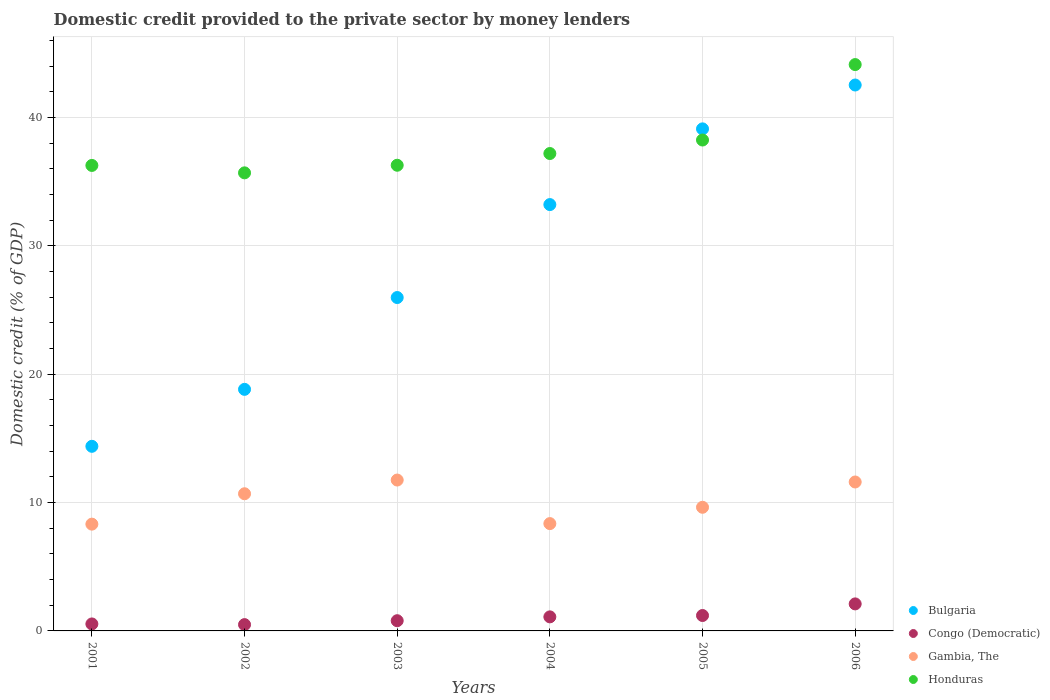How many different coloured dotlines are there?
Give a very brief answer. 4. What is the domestic credit provided to the private sector by money lenders in Gambia, The in 2006?
Provide a short and direct response. 11.61. Across all years, what is the maximum domestic credit provided to the private sector by money lenders in Honduras?
Give a very brief answer. 44.14. Across all years, what is the minimum domestic credit provided to the private sector by money lenders in Bulgaria?
Keep it short and to the point. 14.39. In which year was the domestic credit provided to the private sector by money lenders in Gambia, The maximum?
Keep it short and to the point. 2003. In which year was the domestic credit provided to the private sector by money lenders in Congo (Democratic) minimum?
Ensure brevity in your answer.  2002. What is the total domestic credit provided to the private sector by money lenders in Gambia, The in the graph?
Provide a succinct answer. 60.38. What is the difference between the domestic credit provided to the private sector by money lenders in Gambia, The in 2001 and that in 2003?
Offer a terse response. -3.44. What is the difference between the domestic credit provided to the private sector by money lenders in Honduras in 2004 and the domestic credit provided to the private sector by money lenders in Gambia, The in 2003?
Make the answer very short. 25.45. What is the average domestic credit provided to the private sector by money lenders in Congo (Democratic) per year?
Your answer should be compact. 1.04. In the year 2006, what is the difference between the domestic credit provided to the private sector by money lenders in Gambia, The and domestic credit provided to the private sector by money lenders in Bulgaria?
Ensure brevity in your answer.  -30.94. What is the ratio of the domestic credit provided to the private sector by money lenders in Honduras in 2002 to that in 2005?
Keep it short and to the point. 0.93. Is the difference between the domestic credit provided to the private sector by money lenders in Gambia, The in 2002 and 2003 greater than the difference between the domestic credit provided to the private sector by money lenders in Bulgaria in 2002 and 2003?
Your response must be concise. Yes. What is the difference between the highest and the second highest domestic credit provided to the private sector by money lenders in Honduras?
Your answer should be compact. 5.88. What is the difference between the highest and the lowest domestic credit provided to the private sector by money lenders in Honduras?
Your answer should be compact. 8.44. In how many years, is the domestic credit provided to the private sector by money lenders in Bulgaria greater than the average domestic credit provided to the private sector by money lenders in Bulgaria taken over all years?
Provide a short and direct response. 3. Is the sum of the domestic credit provided to the private sector by money lenders in Gambia, The in 2003 and 2006 greater than the maximum domestic credit provided to the private sector by money lenders in Honduras across all years?
Ensure brevity in your answer.  No. Is it the case that in every year, the sum of the domestic credit provided to the private sector by money lenders in Honduras and domestic credit provided to the private sector by money lenders in Bulgaria  is greater than the sum of domestic credit provided to the private sector by money lenders in Gambia, The and domestic credit provided to the private sector by money lenders in Congo (Democratic)?
Provide a short and direct response. Yes. Is it the case that in every year, the sum of the domestic credit provided to the private sector by money lenders in Honduras and domestic credit provided to the private sector by money lenders in Congo (Democratic)  is greater than the domestic credit provided to the private sector by money lenders in Bulgaria?
Your answer should be compact. Yes. Does the domestic credit provided to the private sector by money lenders in Honduras monotonically increase over the years?
Ensure brevity in your answer.  No. Is the domestic credit provided to the private sector by money lenders in Bulgaria strictly greater than the domestic credit provided to the private sector by money lenders in Gambia, The over the years?
Your answer should be compact. Yes. How many years are there in the graph?
Provide a succinct answer. 6. Are the values on the major ticks of Y-axis written in scientific E-notation?
Ensure brevity in your answer.  No. Does the graph contain grids?
Ensure brevity in your answer.  Yes. Where does the legend appear in the graph?
Ensure brevity in your answer.  Bottom right. What is the title of the graph?
Provide a succinct answer. Domestic credit provided to the private sector by money lenders. What is the label or title of the Y-axis?
Offer a terse response. Domestic credit (% of GDP). What is the Domestic credit (% of GDP) in Bulgaria in 2001?
Your response must be concise. 14.39. What is the Domestic credit (% of GDP) in Congo (Democratic) in 2001?
Keep it short and to the point. 0.54. What is the Domestic credit (% of GDP) in Gambia, The in 2001?
Provide a succinct answer. 8.32. What is the Domestic credit (% of GDP) in Honduras in 2001?
Your answer should be compact. 36.28. What is the Domestic credit (% of GDP) of Bulgaria in 2002?
Make the answer very short. 18.83. What is the Domestic credit (% of GDP) in Congo (Democratic) in 2002?
Keep it short and to the point. 0.49. What is the Domestic credit (% of GDP) of Gambia, The in 2002?
Provide a short and direct response. 10.69. What is the Domestic credit (% of GDP) of Honduras in 2002?
Your answer should be compact. 35.7. What is the Domestic credit (% of GDP) in Bulgaria in 2003?
Provide a succinct answer. 25.98. What is the Domestic credit (% of GDP) in Congo (Democratic) in 2003?
Provide a succinct answer. 0.8. What is the Domestic credit (% of GDP) in Gambia, The in 2003?
Provide a short and direct response. 11.76. What is the Domestic credit (% of GDP) of Honduras in 2003?
Give a very brief answer. 36.29. What is the Domestic credit (% of GDP) in Bulgaria in 2004?
Your answer should be compact. 33.23. What is the Domestic credit (% of GDP) in Congo (Democratic) in 2004?
Ensure brevity in your answer.  1.1. What is the Domestic credit (% of GDP) of Gambia, The in 2004?
Provide a short and direct response. 8.36. What is the Domestic credit (% of GDP) in Honduras in 2004?
Provide a short and direct response. 37.2. What is the Domestic credit (% of GDP) of Bulgaria in 2005?
Your response must be concise. 39.13. What is the Domestic credit (% of GDP) in Congo (Democratic) in 2005?
Your answer should be very brief. 1.2. What is the Domestic credit (% of GDP) of Gambia, The in 2005?
Provide a succinct answer. 9.64. What is the Domestic credit (% of GDP) in Honduras in 2005?
Keep it short and to the point. 38.26. What is the Domestic credit (% of GDP) in Bulgaria in 2006?
Offer a terse response. 42.54. What is the Domestic credit (% of GDP) of Congo (Democratic) in 2006?
Offer a terse response. 2.11. What is the Domestic credit (% of GDP) in Gambia, The in 2006?
Provide a short and direct response. 11.61. What is the Domestic credit (% of GDP) in Honduras in 2006?
Ensure brevity in your answer.  44.14. Across all years, what is the maximum Domestic credit (% of GDP) in Bulgaria?
Make the answer very short. 42.54. Across all years, what is the maximum Domestic credit (% of GDP) of Congo (Democratic)?
Provide a succinct answer. 2.11. Across all years, what is the maximum Domestic credit (% of GDP) in Gambia, The?
Ensure brevity in your answer.  11.76. Across all years, what is the maximum Domestic credit (% of GDP) in Honduras?
Offer a very short reply. 44.14. Across all years, what is the minimum Domestic credit (% of GDP) in Bulgaria?
Offer a very short reply. 14.39. Across all years, what is the minimum Domestic credit (% of GDP) in Congo (Democratic)?
Your answer should be very brief. 0.49. Across all years, what is the minimum Domestic credit (% of GDP) of Gambia, The?
Offer a terse response. 8.32. Across all years, what is the minimum Domestic credit (% of GDP) of Honduras?
Your answer should be compact. 35.7. What is the total Domestic credit (% of GDP) of Bulgaria in the graph?
Give a very brief answer. 174.09. What is the total Domestic credit (% of GDP) in Congo (Democratic) in the graph?
Make the answer very short. 6.23. What is the total Domestic credit (% of GDP) in Gambia, The in the graph?
Your answer should be compact. 60.38. What is the total Domestic credit (% of GDP) in Honduras in the graph?
Ensure brevity in your answer.  227.86. What is the difference between the Domestic credit (% of GDP) of Bulgaria in 2001 and that in 2002?
Keep it short and to the point. -4.44. What is the difference between the Domestic credit (% of GDP) of Congo (Democratic) in 2001 and that in 2002?
Your response must be concise. 0.05. What is the difference between the Domestic credit (% of GDP) of Gambia, The in 2001 and that in 2002?
Your response must be concise. -2.37. What is the difference between the Domestic credit (% of GDP) of Honduras in 2001 and that in 2002?
Your answer should be compact. 0.58. What is the difference between the Domestic credit (% of GDP) of Bulgaria in 2001 and that in 2003?
Provide a succinct answer. -11.59. What is the difference between the Domestic credit (% of GDP) in Congo (Democratic) in 2001 and that in 2003?
Make the answer very short. -0.25. What is the difference between the Domestic credit (% of GDP) in Gambia, The in 2001 and that in 2003?
Provide a short and direct response. -3.44. What is the difference between the Domestic credit (% of GDP) in Honduras in 2001 and that in 2003?
Your answer should be very brief. -0.01. What is the difference between the Domestic credit (% of GDP) of Bulgaria in 2001 and that in 2004?
Give a very brief answer. -18.84. What is the difference between the Domestic credit (% of GDP) in Congo (Democratic) in 2001 and that in 2004?
Give a very brief answer. -0.55. What is the difference between the Domestic credit (% of GDP) of Gambia, The in 2001 and that in 2004?
Your answer should be compact. -0.04. What is the difference between the Domestic credit (% of GDP) in Honduras in 2001 and that in 2004?
Make the answer very short. -0.93. What is the difference between the Domestic credit (% of GDP) in Bulgaria in 2001 and that in 2005?
Your response must be concise. -24.74. What is the difference between the Domestic credit (% of GDP) in Congo (Democratic) in 2001 and that in 2005?
Your response must be concise. -0.66. What is the difference between the Domestic credit (% of GDP) of Gambia, The in 2001 and that in 2005?
Your response must be concise. -1.31. What is the difference between the Domestic credit (% of GDP) of Honduras in 2001 and that in 2005?
Give a very brief answer. -1.98. What is the difference between the Domestic credit (% of GDP) of Bulgaria in 2001 and that in 2006?
Offer a terse response. -28.16. What is the difference between the Domestic credit (% of GDP) in Congo (Democratic) in 2001 and that in 2006?
Ensure brevity in your answer.  -1.56. What is the difference between the Domestic credit (% of GDP) in Gambia, The in 2001 and that in 2006?
Offer a very short reply. -3.29. What is the difference between the Domestic credit (% of GDP) in Honduras in 2001 and that in 2006?
Keep it short and to the point. -7.86. What is the difference between the Domestic credit (% of GDP) in Bulgaria in 2002 and that in 2003?
Provide a succinct answer. -7.16. What is the difference between the Domestic credit (% of GDP) in Congo (Democratic) in 2002 and that in 2003?
Your response must be concise. -0.3. What is the difference between the Domestic credit (% of GDP) in Gambia, The in 2002 and that in 2003?
Provide a short and direct response. -1.07. What is the difference between the Domestic credit (% of GDP) of Honduras in 2002 and that in 2003?
Offer a very short reply. -0.59. What is the difference between the Domestic credit (% of GDP) in Bulgaria in 2002 and that in 2004?
Offer a terse response. -14.4. What is the difference between the Domestic credit (% of GDP) of Congo (Democratic) in 2002 and that in 2004?
Provide a succinct answer. -0.6. What is the difference between the Domestic credit (% of GDP) of Gambia, The in 2002 and that in 2004?
Your response must be concise. 2.33. What is the difference between the Domestic credit (% of GDP) of Honduras in 2002 and that in 2004?
Your answer should be very brief. -1.51. What is the difference between the Domestic credit (% of GDP) in Bulgaria in 2002 and that in 2005?
Your answer should be very brief. -20.3. What is the difference between the Domestic credit (% of GDP) in Congo (Democratic) in 2002 and that in 2005?
Your answer should be very brief. -0.71. What is the difference between the Domestic credit (% of GDP) of Gambia, The in 2002 and that in 2005?
Provide a short and direct response. 1.05. What is the difference between the Domestic credit (% of GDP) in Honduras in 2002 and that in 2005?
Your response must be concise. -2.56. What is the difference between the Domestic credit (% of GDP) in Bulgaria in 2002 and that in 2006?
Ensure brevity in your answer.  -23.72. What is the difference between the Domestic credit (% of GDP) in Congo (Democratic) in 2002 and that in 2006?
Your response must be concise. -1.61. What is the difference between the Domestic credit (% of GDP) of Gambia, The in 2002 and that in 2006?
Give a very brief answer. -0.92. What is the difference between the Domestic credit (% of GDP) in Honduras in 2002 and that in 2006?
Offer a terse response. -8.44. What is the difference between the Domestic credit (% of GDP) of Bulgaria in 2003 and that in 2004?
Offer a terse response. -7.24. What is the difference between the Domestic credit (% of GDP) of Congo (Democratic) in 2003 and that in 2004?
Your response must be concise. -0.3. What is the difference between the Domestic credit (% of GDP) of Gambia, The in 2003 and that in 2004?
Your answer should be very brief. 3.39. What is the difference between the Domestic credit (% of GDP) in Honduras in 2003 and that in 2004?
Give a very brief answer. -0.91. What is the difference between the Domestic credit (% of GDP) of Bulgaria in 2003 and that in 2005?
Provide a short and direct response. -13.14. What is the difference between the Domestic credit (% of GDP) of Congo (Democratic) in 2003 and that in 2005?
Offer a terse response. -0.41. What is the difference between the Domestic credit (% of GDP) in Gambia, The in 2003 and that in 2005?
Provide a short and direct response. 2.12. What is the difference between the Domestic credit (% of GDP) in Honduras in 2003 and that in 2005?
Keep it short and to the point. -1.97. What is the difference between the Domestic credit (% of GDP) of Bulgaria in 2003 and that in 2006?
Make the answer very short. -16.56. What is the difference between the Domestic credit (% of GDP) of Congo (Democratic) in 2003 and that in 2006?
Provide a succinct answer. -1.31. What is the difference between the Domestic credit (% of GDP) of Gambia, The in 2003 and that in 2006?
Your answer should be very brief. 0.15. What is the difference between the Domestic credit (% of GDP) of Honduras in 2003 and that in 2006?
Provide a succinct answer. -7.85. What is the difference between the Domestic credit (% of GDP) in Bulgaria in 2004 and that in 2005?
Keep it short and to the point. -5.9. What is the difference between the Domestic credit (% of GDP) in Congo (Democratic) in 2004 and that in 2005?
Give a very brief answer. -0.11. What is the difference between the Domestic credit (% of GDP) in Gambia, The in 2004 and that in 2005?
Offer a terse response. -1.27. What is the difference between the Domestic credit (% of GDP) of Honduras in 2004 and that in 2005?
Provide a short and direct response. -1.05. What is the difference between the Domestic credit (% of GDP) of Bulgaria in 2004 and that in 2006?
Provide a short and direct response. -9.32. What is the difference between the Domestic credit (% of GDP) in Congo (Democratic) in 2004 and that in 2006?
Offer a very short reply. -1.01. What is the difference between the Domestic credit (% of GDP) of Gambia, The in 2004 and that in 2006?
Give a very brief answer. -3.24. What is the difference between the Domestic credit (% of GDP) in Honduras in 2004 and that in 2006?
Your answer should be very brief. -6.93. What is the difference between the Domestic credit (% of GDP) in Bulgaria in 2005 and that in 2006?
Your response must be concise. -3.42. What is the difference between the Domestic credit (% of GDP) in Congo (Democratic) in 2005 and that in 2006?
Make the answer very short. -0.9. What is the difference between the Domestic credit (% of GDP) of Gambia, The in 2005 and that in 2006?
Your answer should be very brief. -1.97. What is the difference between the Domestic credit (% of GDP) of Honduras in 2005 and that in 2006?
Offer a terse response. -5.88. What is the difference between the Domestic credit (% of GDP) in Bulgaria in 2001 and the Domestic credit (% of GDP) in Congo (Democratic) in 2002?
Offer a very short reply. 13.9. What is the difference between the Domestic credit (% of GDP) in Bulgaria in 2001 and the Domestic credit (% of GDP) in Gambia, The in 2002?
Make the answer very short. 3.7. What is the difference between the Domestic credit (% of GDP) of Bulgaria in 2001 and the Domestic credit (% of GDP) of Honduras in 2002?
Make the answer very short. -21.31. What is the difference between the Domestic credit (% of GDP) of Congo (Democratic) in 2001 and the Domestic credit (% of GDP) of Gambia, The in 2002?
Give a very brief answer. -10.15. What is the difference between the Domestic credit (% of GDP) of Congo (Democratic) in 2001 and the Domestic credit (% of GDP) of Honduras in 2002?
Ensure brevity in your answer.  -35.15. What is the difference between the Domestic credit (% of GDP) in Gambia, The in 2001 and the Domestic credit (% of GDP) in Honduras in 2002?
Provide a succinct answer. -27.38. What is the difference between the Domestic credit (% of GDP) in Bulgaria in 2001 and the Domestic credit (% of GDP) in Congo (Democratic) in 2003?
Your answer should be very brief. 13.59. What is the difference between the Domestic credit (% of GDP) in Bulgaria in 2001 and the Domestic credit (% of GDP) in Gambia, The in 2003?
Offer a terse response. 2.63. What is the difference between the Domestic credit (% of GDP) in Bulgaria in 2001 and the Domestic credit (% of GDP) in Honduras in 2003?
Provide a short and direct response. -21.9. What is the difference between the Domestic credit (% of GDP) in Congo (Democratic) in 2001 and the Domestic credit (% of GDP) in Gambia, The in 2003?
Your answer should be compact. -11.21. What is the difference between the Domestic credit (% of GDP) in Congo (Democratic) in 2001 and the Domestic credit (% of GDP) in Honduras in 2003?
Your answer should be compact. -35.75. What is the difference between the Domestic credit (% of GDP) in Gambia, The in 2001 and the Domestic credit (% of GDP) in Honduras in 2003?
Your answer should be very brief. -27.97. What is the difference between the Domestic credit (% of GDP) in Bulgaria in 2001 and the Domestic credit (% of GDP) in Congo (Democratic) in 2004?
Make the answer very short. 13.29. What is the difference between the Domestic credit (% of GDP) in Bulgaria in 2001 and the Domestic credit (% of GDP) in Gambia, The in 2004?
Give a very brief answer. 6.02. What is the difference between the Domestic credit (% of GDP) in Bulgaria in 2001 and the Domestic credit (% of GDP) in Honduras in 2004?
Your response must be concise. -22.82. What is the difference between the Domestic credit (% of GDP) in Congo (Democratic) in 2001 and the Domestic credit (% of GDP) in Gambia, The in 2004?
Your response must be concise. -7.82. What is the difference between the Domestic credit (% of GDP) in Congo (Democratic) in 2001 and the Domestic credit (% of GDP) in Honduras in 2004?
Ensure brevity in your answer.  -36.66. What is the difference between the Domestic credit (% of GDP) in Gambia, The in 2001 and the Domestic credit (% of GDP) in Honduras in 2004?
Provide a succinct answer. -28.88. What is the difference between the Domestic credit (% of GDP) in Bulgaria in 2001 and the Domestic credit (% of GDP) in Congo (Democratic) in 2005?
Offer a terse response. 13.19. What is the difference between the Domestic credit (% of GDP) of Bulgaria in 2001 and the Domestic credit (% of GDP) of Gambia, The in 2005?
Ensure brevity in your answer.  4.75. What is the difference between the Domestic credit (% of GDP) of Bulgaria in 2001 and the Domestic credit (% of GDP) of Honduras in 2005?
Make the answer very short. -23.87. What is the difference between the Domestic credit (% of GDP) in Congo (Democratic) in 2001 and the Domestic credit (% of GDP) in Gambia, The in 2005?
Give a very brief answer. -9.09. What is the difference between the Domestic credit (% of GDP) in Congo (Democratic) in 2001 and the Domestic credit (% of GDP) in Honduras in 2005?
Offer a terse response. -37.71. What is the difference between the Domestic credit (% of GDP) in Gambia, The in 2001 and the Domestic credit (% of GDP) in Honduras in 2005?
Keep it short and to the point. -29.94. What is the difference between the Domestic credit (% of GDP) of Bulgaria in 2001 and the Domestic credit (% of GDP) of Congo (Democratic) in 2006?
Keep it short and to the point. 12.28. What is the difference between the Domestic credit (% of GDP) of Bulgaria in 2001 and the Domestic credit (% of GDP) of Gambia, The in 2006?
Provide a short and direct response. 2.78. What is the difference between the Domestic credit (% of GDP) in Bulgaria in 2001 and the Domestic credit (% of GDP) in Honduras in 2006?
Offer a very short reply. -29.75. What is the difference between the Domestic credit (% of GDP) in Congo (Democratic) in 2001 and the Domestic credit (% of GDP) in Gambia, The in 2006?
Make the answer very short. -11.06. What is the difference between the Domestic credit (% of GDP) of Congo (Democratic) in 2001 and the Domestic credit (% of GDP) of Honduras in 2006?
Give a very brief answer. -43.59. What is the difference between the Domestic credit (% of GDP) of Gambia, The in 2001 and the Domestic credit (% of GDP) of Honduras in 2006?
Ensure brevity in your answer.  -35.81. What is the difference between the Domestic credit (% of GDP) in Bulgaria in 2002 and the Domestic credit (% of GDP) in Congo (Democratic) in 2003?
Offer a very short reply. 18.03. What is the difference between the Domestic credit (% of GDP) in Bulgaria in 2002 and the Domestic credit (% of GDP) in Gambia, The in 2003?
Your response must be concise. 7.07. What is the difference between the Domestic credit (% of GDP) in Bulgaria in 2002 and the Domestic credit (% of GDP) in Honduras in 2003?
Provide a short and direct response. -17.46. What is the difference between the Domestic credit (% of GDP) in Congo (Democratic) in 2002 and the Domestic credit (% of GDP) in Gambia, The in 2003?
Give a very brief answer. -11.27. What is the difference between the Domestic credit (% of GDP) of Congo (Democratic) in 2002 and the Domestic credit (% of GDP) of Honduras in 2003?
Provide a short and direct response. -35.8. What is the difference between the Domestic credit (% of GDP) of Gambia, The in 2002 and the Domestic credit (% of GDP) of Honduras in 2003?
Your response must be concise. -25.6. What is the difference between the Domestic credit (% of GDP) in Bulgaria in 2002 and the Domestic credit (% of GDP) in Congo (Democratic) in 2004?
Offer a very short reply. 17.73. What is the difference between the Domestic credit (% of GDP) of Bulgaria in 2002 and the Domestic credit (% of GDP) of Gambia, The in 2004?
Offer a very short reply. 10.46. What is the difference between the Domestic credit (% of GDP) in Bulgaria in 2002 and the Domestic credit (% of GDP) in Honduras in 2004?
Your answer should be compact. -18.38. What is the difference between the Domestic credit (% of GDP) in Congo (Democratic) in 2002 and the Domestic credit (% of GDP) in Gambia, The in 2004?
Make the answer very short. -7.87. What is the difference between the Domestic credit (% of GDP) of Congo (Democratic) in 2002 and the Domestic credit (% of GDP) of Honduras in 2004?
Ensure brevity in your answer.  -36.71. What is the difference between the Domestic credit (% of GDP) of Gambia, The in 2002 and the Domestic credit (% of GDP) of Honduras in 2004?
Offer a terse response. -26.51. What is the difference between the Domestic credit (% of GDP) in Bulgaria in 2002 and the Domestic credit (% of GDP) in Congo (Democratic) in 2005?
Provide a succinct answer. 17.62. What is the difference between the Domestic credit (% of GDP) in Bulgaria in 2002 and the Domestic credit (% of GDP) in Gambia, The in 2005?
Provide a short and direct response. 9.19. What is the difference between the Domestic credit (% of GDP) in Bulgaria in 2002 and the Domestic credit (% of GDP) in Honduras in 2005?
Offer a very short reply. -19.43. What is the difference between the Domestic credit (% of GDP) of Congo (Democratic) in 2002 and the Domestic credit (% of GDP) of Gambia, The in 2005?
Provide a short and direct response. -9.14. What is the difference between the Domestic credit (% of GDP) of Congo (Democratic) in 2002 and the Domestic credit (% of GDP) of Honduras in 2005?
Your answer should be very brief. -37.77. What is the difference between the Domestic credit (% of GDP) in Gambia, The in 2002 and the Domestic credit (% of GDP) in Honduras in 2005?
Provide a short and direct response. -27.57. What is the difference between the Domestic credit (% of GDP) in Bulgaria in 2002 and the Domestic credit (% of GDP) in Congo (Democratic) in 2006?
Keep it short and to the point. 16.72. What is the difference between the Domestic credit (% of GDP) in Bulgaria in 2002 and the Domestic credit (% of GDP) in Gambia, The in 2006?
Offer a very short reply. 7.22. What is the difference between the Domestic credit (% of GDP) in Bulgaria in 2002 and the Domestic credit (% of GDP) in Honduras in 2006?
Your response must be concise. -25.31. What is the difference between the Domestic credit (% of GDP) in Congo (Democratic) in 2002 and the Domestic credit (% of GDP) in Gambia, The in 2006?
Provide a succinct answer. -11.12. What is the difference between the Domestic credit (% of GDP) of Congo (Democratic) in 2002 and the Domestic credit (% of GDP) of Honduras in 2006?
Your answer should be very brief. -43.64. What is the difference between the Domestic credit (% of GDP) in Gambia, The in 2002 and the Domestic credit (% of GDP) in Honduras in 2006?
Keep it short and to the point. -33.45. What is the difference between the Domestic credit (% of GDP) of Bulgaria in 2003 and the Domestic credit (% of GDP) of Congo (Democratic) in 2004?
Provide a short and direct response. 24.89. What is the difference between the Domestic credit (% of GDP) in Bulgaria in 2003 and the Domestic credit (% of GDP) in Gambia, The in 2004?
Ensure brevity in your answer.  17.62. What is the difference between the Domestic credit (% of GDP) in Bulgaria in 2003 and the Domestic credit (% of GDP) in Honduras in 2004?
Your response must be concise. -11.22. What is the difference between the Domestic credit (% of GDP) of Congo (Democratic) in 2003 and the Domestic credit (% of GDP) of Gambia, The in 2004?
Make the answer very short. -7.57. What is the difference between the Domestic credit (% of GDP) in Congo (Democratic) in 2003 and the Domestic credit (% of GDP) in Honduras in 2004?
Provide a short and direct response. -36.41. What is the difference between the Domestic credit (% of GDP) of Gambia, The in 2003 and the Domestic credit (% of GDP) of Honduras in 2004?
Offer a very short reply. -25.45. What is the difference between the Domestic credit (% of GDP) in Bulgaria in 2003 and the Domestic credit (% of GDP) in Congo (Democratic) in 2005?
Offer a terse response. 24.78. What is the difference between the Domestic credit (% of GDP) of Bulgaria in 2003 and the Domestic credit (% of GDP) of Gambia, The in 2005?
Offer a terse response. 16.35. What is the difference between the Domestic credit (% of GDP) of Bulgaria in 2003 and the Domestic credit (% of GDP) of Honduras in 2005?
Your answer should be compact. -12.28. What is the difference between the Domestic credit (% of GDP) of Congo (Democratic) in 2003 and the Domestic credit (% of GDP) of Gambia, The in 2005?
Ensure brevity in your answer.  -8.84. What is the difference between the Domestic credit (% of GDP) in Congo (Democratic) in 2003 and the Domestic credit (% of GDP) in Honduras in 2005?
Your answer should be very brief. -37.46. What is the difference between the Domestic credit (% of GDP) of Gambia, The in 2003 and the Domestic credit (% of GDP) of Honduras in 2005?
Your answer should be very brief. -26.5. What is the difference between the Domestic credit (% of GDP) in Bulgaria in 2003 and the Domestic credit (% of GDP) in Congo (Democratic) in 2006?
Provide a succinct answer. 23.88. What is the difference between the Domestic credit (% of GDP) of Bulgaria in 2003 and the Domestic credit (% of GDP) of Gambia, The in 2006?
Your answer should be compact. 14.37. What is the difference between the Domestic credit (% of GDP) in Bulgaria in 2003 and the Domestic credit (% of GDP) in Honduras in 2006?
Provide a succinct answer. -18.15. What is the difference between the Domestic credit (% of GDP) of Congo (Democratic) in 2003 and the Domestic credit (% of GDP) of Gambia, The in 2006?
Your answer should be very brief. -10.81. What is the difference between the Domestic credit (% of GDP) in Congo (Democratic) in 2003 and the Domestic credit (% of GDP) in Honduras in 2006?
Give a very brief answer. -43.34. What is the difference between the Domestic credit (% of GDP) of Gambia, The in 2003 and the Domestic credit (% of GDP) of Honduras in 2006?
Make the answer very short. -32.38. What is the difference between the Domestic credit (% of GDP) of Bulgaria in 2004 and the Domestic credit (% of GDP) of Congo (Democratic) in 2005?
Your answer should be very brief. 32.02. What is the difference between the Domestic credit (% of GDP) in Bulgaria in 2004 and the Domestic credit (% of GDP) in Gambia, The in 2005?
Ensure brevity in your answer.  23.59. What is the difference between the Domestic credit (% of GDP) of Bulgaria in 2004 and the Domestic credit (% of GDP) of Honduras in 2005?
Your answer should be very brief. -5.03. What is the difference between the Domestic credit (% of GDP) of Congo (Democratic) in 2004 and the Domestic credit (% of GDP) of Gambia, The in 2005?
Offer a terse response. -8.54. What is the difference between the Domestic credit (% of GDP) of Congo (Democratic) in 2004 and the Domestic credit (% of GDP) of Honduras in 2005?
Your answer should be compact. -37.16. What is the difference between the Domestic credit (% of GDP) in Gambia, The in 2004 and the Domestic credit (% of GDP) in Honduras in 2005?
Make the answer very short. -29.89. What is the difference between the Domestic credit (% of GDP) of Bulgaria in 2004 and the Domestic credit (% of GDP) of Congo (Democratic) in 2006?
Your response must be concise. 31.12. What is the difference between the Domestic credit (% of GDP) of Bulgaria in 2004 and the Domestic credit (% of GDP) of Gambia, The in 2006?
Ensure brevity in your answer.  21.62. What is the difference between the Domestic credit (% of GDP) in Bulgaria in 2004 and the Domestic credit (% of GDP) in Honduras in 2006?
Provide a succinct answer. -10.91. What is the difference between the Domestic credit (% of GDP) in Congo (Democratic) in 2004 and the Domestic credit (% of GDP) in Gambia, The in 2006?
Keep it short and to the point. -10.51. What is the difference between the Domestic credit (% of GDP) in Congo (Democratic) in 2004 and the Domestic credit (% of GDP) in Honduras in 2006?
Provide a succinct answer. -43.04. What is the difference between the Domestic credit (% of GDP) of Gambia, The in 2004 and the Domestic credit (% of GDP) of Honduras in 2006?
Ensure brevity in your answer.  -35.77. What is the difference between the Domestic credit (% of GDP) of Bulgaria in 2005 and the Domestic credit (% of GDP) of Congo (Democratic) in 2006?
Provide a short and direct response. 37.02. What is the difference between the Domestic credit (% of GDP) in Bulgaria in 2005 and the Domestic credit (% of GDP) in Gambia, The in 2006?
Provide a succinct answer. 27.52. What is the difference between the Domestic credit (% of GDP) in Bulgaria in 2005 and the Domestic credit (% of GDP) in Honduras in 2006?
Provide a short and direct response. -5.01. What is the difference between the Domestic credit (% of GDP) of Congo (Democratic) in 2005 and the Domestic credit (% of GDP) of Gambia, The in 2006?
Offer a terse response. -10.41. What is the difference between the Domestic credit (% of GDP) of Congo (Democratic) in 2005 and the Domestic credit (% of GDP) of Honduras in 2006?
Give a very brief answer. -42.94. What is the difference between the Domestic credit (% of GDP) of Gambia, The in 2005 and the Domestic credit (% of GDP) of Honduras in 2006?
Provide a short and direct response. -34.5. What is the average Domestic credit (% of GDP) of Bulgaria per year?
Ensure brevity in your answer.  29.01. What is the average Domestic credit (% of GDP) in Congo (Democratic) per year?
Provide a succinct answer. 1.04. What is the average Domestic credit (% of GDP) of Gambia, The per year?
Offer a terse response. 10.06. What is the average Domestic credit (% of GDP) of Honduras per year?
Ensure brevity in your answer.  37.98. In the year 2001, what is the difference between the Domestic credit (% of GDP) of Bulgaria and Domestic credit (% of GDP) of Congo (Democratic)?
Offer a very short reply. 13.84. In the year 2001, what is the difference between the Domestic credit (% of GDP) in Bulgaria and Domestic credit (% of GDP) in Gambia, The?
Offer a terse response. 6.07. In the year 2001, what is the difference between the Domestic credit (% of GDP) of Bulgaria and Domestic credit (% of GDP) of Honduras?
Your response must be concise. -21.89. In the year 2001, what is the difference between the Domestic credit (% of GDP) in Congo (Democratic) and Domestic credit (% of GDP) in Gambia, The?
Keep it short and to the point. -7.78. In the year 2001, what is the difference between the Domestic credit (% of GDP) in Congo (Democratic) and Domestic credit (% of GDP) in Honduras?
Keep it short and to the point. -35.73. In the year 2001, what is the difference between the Domestic credit (% of GDP) of Gambia, The and Domestic credit (% of GDP) of Honduras?
Make the answer very short. -27.95. In the year 2002, what is the difference between the Domestic credit (% of GDP) in Bulgaria and Domestic credit (% of GDP) in Congo (Democratic)?
Provide a short and direct response. 18.33. In the year 2002, what is the difference between the Domestic credit (% of GDP) in Bulgaria and Domestic credit (% of GDP) in Gambia, The?
Offer a very short reply. 8.14. In the year 2002, what is the difference between the Domestic credit (% of GDP) of Bulgaria and Domestic credit (% of GDP) of Honduras?
Offer a very short reply. -16.87. In the year 2002, what is the difference between the Domestic credit (% of GDP) in Congo (Democratic) and Domestic credit (% of GDP) in Gambia, The?
Make the answer very short. -10.2. In the year 2002, what is the difference between the Domestic credit (% of GDP) of Congo (Democratic) and Domestic credit (% of GDP) of Honduras?
Make the answer very short. -35.21. In the year 2002, what is the difference between the Domestic credit (% of GDP) of Gambia, The and Domestic credit (% of GDP) of Honduras?
Your response must be concise. -25.01. In the year 2003, what is the difference between the Domestic credit (% of GDP) of Bulgaria and Domestic credit (% of GDP) of Congo (Democratic)?
Your answer should be compact. 25.19. In the year 2003, what is the difference between the Domestic credit (% of GDP) in Bulgaria and Domestic credit (% of GDP) in Gambia, The?
Provide a short and direct response. 14.22. In the year 2003, what is the difference between the Domestic credit (% of GDP) of Bulgaria and Domestic credit (% of GDP) of Honduras?
Offer a very short reply. -10.31. In the year 2003, what is the difference between the Domestic credit (% of GDP) of Congo (Democratic) and Domestic credit (% of GDP) of Gambia, The?
Offer a terse response. -10.96. In the year 2003, what is the difference between the Domestic credit (% of GDP) of Congo (Democratic) and Domestic credit (% of GDP) of Honduras?
Your answer should be very brief. -35.49. In the year 2003, what is the difference between the Domestic credit (% of GDP) in Gambia, The and Domestic credit (% of GDP) in Honduras?
Make the answer very short. -24.53. In the year 2004, what is the difference between the Domestic credit (% of GDP) in Bulgaria and Domestic credit (% of GDP) in Congo (Democratic)?
Provide a short and direct response. 32.13. In the year 2004, what is the difference between the Domestic credit (% of GDP) of Bulgaria and Domestic credit (% of GDP) of Gambia, The?
Your response must be concise. 24.86. In the year 2004, what is the difference between the Domestic credit (% of GDP) in Bulgaria and Domestic credit (% of GDP) in Honduras?
Offer a terse response. -3.98. In the year 2004, what is the difference between the Domestic credit (% of GDP) in Congo (Democratic) and Domestic credit (% of GDP) in Gambia, The?
Your answer should be very brief. -7.27. In the year 2004, what is the difference between the Domestic credit (% of GDP) in Congo (Democratic) and Domestic credit (% of GDP) in Honduras?
Keep it short and to the point. -36.11. In the year 2004, what is the difference between the Domestic credit (% of GDP) in Gambia, The and Domestic credit (% of GDP) in Honduras?
Your answer should be compact. -28.84. In the year 2005, what is the difference between the Domestic credit (% of GDP) in Bulgaria and Domestic credit (% of GDP) in Congo (Democratic)?
Your answer should be compact. 37.92. In the year 2005, what is the difference between the Domestic credit (% of GDP) in Bulgaria and Domestic credit (% of GDP) in Gambia, The?
Your answer should be very brief. 29.49. In the year 2005, what is the difference between the Domestic credit (% of GDP) of Bulgaria and Domestic credit (% of GDP) of Honduras?
Provide a short and direct response. 0.87. In the year 2005, what is the difference between the Domestic credit (% of GDP) in Congo (Democratic) and Domestic credit (% of GDP) in Gambia, The?
Your answer should be compact. -8.43. In the year 2005, what is the difference between the Domestic credit (% of GDP) in Congo (Democratic) and Domestic credit (% of GDP) in Honduras?
Your answer should be compact. -37.06. In the year 2005, what is the difference between the Domestic credit (% of GDP) in Gambia, The and Domestic credit (% of GDP) in Honduras?
Provide a succinct answer. -28.62. In the year 2006, what is the difference between the Domestic credit (% of GDP) in Bulgaria and Domestic credit (% of GDP) in Congo (Democratic)?
Offer a terse response. 40.44. In the year 2006, what is the difference between the Domestic credit (% of GDP) in Bulgaria and Domestic credit (% of GDP) in Gambia, The?
Provide a succinct answer. 30.94. In the year 2006, what is the difference between the Domestic credit (% of GDP) in Bulgaria and Domestic credit (% of GDP) in Honduras?
Provide a short and direct response. -1.59. In the year 2006, what is the difference between the Domestic credit (% of GDP) of Congo (Democratic) and Domestic credit (% of GDP) of Gambia, The?
Your answer should be compact. -9.5. In the year 2006, what is the difference between the Domestic credit (% of GDP) in Congo (Democratic) and Domestic credit (% of GDP) in Honduras?
Ensure brevity in your answer.  -42.03. In the year 2006, what is the difference between the Domestic credit (% of GDP) in Gambia, The and Domestic credit (% of GDP) in Honduras?
Make the answer very short. -32.53. What is the ratio of the Domestic credit (% of GDP) in Bulgaria in 2001 to that in 2002?
Give a very brief answer. 0.76. What is the ratio of the Domestic credit (% of GDP) of Congo (Democratic) in 2001 to that in 2002?
Provide a succinct answer. 1.11. What is the ratio of the Domestic credit (% of GDP) in Gambia, The in 2001 to that in 2002?
Keep it short and to the point. 0.78. What is the ratio of the Domestic credit (% of GDP) in Honduras in 2001 to that in 2002?
Provide a succinct answer. 1.02. What is the ratio of the Domestic credit (% of GDP) in Bulgaria in 2001 to that in 2003?
Make the answer very short. 0.55. What is the ratio of the Domestic credit (% of GDP) in Congo (Democratic) in 2001 to that in 2003?
Ensure brevity in your answer.  0.68. What is the ratio of the Domestic credit (% of GDP) in Gambia, The in 2001 to that in 2003?
Ensure brevity in your answer.  0.71. What is the ratio of the Domestic credit (% of GDP) of Bulgaria in 2001 to that in 2004?
Make the answer very short. 0.43. What is the ratio of the Domestic credit (% of GDP) of Congo (Democratic) in 2001 to that in 2004?
Make the answer very short. 0.5. What is the ratio of the Domestic credit (% of GDP) in Gambia, The in 2001 to that in 2004?
Provide a succinct answer. 0.99. What is the ratio of the Domestic credit (% of GDP) of Honduras in 2001 to that in 2004?
Your answer should be very brief. 0.98. What is the ratio of the Domestic credit (% of GDP) of Bulgaria in 2001 to that in 2005?
Your answer should be very brief. 0.37. What is the ratio of the Domestic credit (% of GDP) of Congo (Democratic) in 2001 to that in 2005?
Make the answer very short. 0.45. What is the ratio of the Domestic credit (% of GDP) of Gambia, The in 2001 to that in 2005?
Your answer should be very brief. 0.86. What is the ratio of the Domestic credit (% of GDP) in Honduras in 2001 to that in 2005?
Provide a succinct answer. 0.95. What is the ratio of the Domestic credit (% of GDP) in Bulgaria in 2001 to that in 2006?
Provide a short and direct response. 0.34. What is the ratio of the Domestic credit (% of GDP) in Congo (Democratic) in 2001 to that in 2006?
Provide a succinct answer. 0.26. What is the ratio of the Domestic credit (% of GDP) of Gambia, The in 2001 to that in 2006?
Your answer should be very brief. 0.72. What is the ratio of the Domestic credit (% of GDP) in Honduras in 2001 to that in 2006?
Keep it short and to the point. 0.82. What is the ratio of the Domestic credit (% of GDP) in Bulgaria in 2002 to that in 2003?
Offer a very short reply. 0.72. What is the ratio of the Domestic credit (% of GDP) in Congo (Democratic) in 2002 to that in 2003?
Ensure brevity in your answer.  0.62. What is the ratio of the Domestic credit (% of GDP) in Gambia, The in 2002 to that in 2003?
Your answer should be very brief. 0.91. What is the ratio of the Domestic credit (% of GDP) of Honduras in 2002 to that in 2003?
Provide a short and direct response. 0.98. What is the ratio of the Domestic credit (% of GDP) in Bulgaria in 2002 to that in 2004?
Make the answer very short. 0.57. What is the ratio of the Domestic credit (% of GDP) of Congo (Democratic) in 2002 to that in 2004?
Your answer should be compact. 0.45. What is the ratio of the Domestic credit (% of GDP) in Gambia, The in 2002 to that in 2004?
Your answer should be very brief. 1.28. What is the ratio of the Domestic credit (% of GDP) in Honduras in 2002 to that in 2004?
Your answer should be very brief. 0.96. What is the ratio of the Domestic credit (% of GDP) of Bulgaria in 2002 to that in 2005?
Your answer should be very brief. 0.48. What is the ratio of the Domestic credit (% of GDP) in Congo (Democratic) in 2002 to that in 2005?
Your response must be concise. 0.41. What is the ratio of the Domestic credit (% of GDP) in Gambia, The in 2002 to that in 2005?
Provide a short and direct response. 1.11. What is the ratio of the Domestic credit (% of GDP) in Honduras in 2002 to that in 2005?
Ensure brevity in your answer.  0.93. What is the ratio of the Domestic credit (% of GDP) in Bulgaria in 2002 to that in 2006?
Make the answer very short. 0.44. What is the ratio of the Domestic credit (% of GDP) in Congo (Democratic) in 2002 to that in 2006?
Your answer should be very brief. 0.23. What is the ratio of the Domestic credit (% of GDP) of Gambia, The in 2002 to that in 2006?
Provide a succinct answer. 0.92. What is the ratio of the Domestic credit (% of GDP) in Honduras in 2002 to that in 2006?
Offer a terse response. 0.81. What is the ratio of the Domestic credit (% of GDP) of Bulgaria in 2003 to that in 2004?
Your answer should be compact. 0.78. What is the ratio of the Domestic credit (% of GDP) of Congo (Democratic) in 2003 to that in 2004?
Your response must be concise. 0.73. What is the ratio of the Domestic credit (% of GDP) of Gambia, The in 2003 to that in 2004?
Provide a short and direct response. 1.41. What is the ratio of the Domestic credit (% of GDP) in Honduras in 2003 to that in 2004?
Your answer should be compact. 0.98. What is the ratio of the Domestic credit (% of GDP) in Bulgaria in 2003 to that in 2005?
Keep it short and to the point. 0.66. What is the ratio of the Domestic credit (% of GDP) in Congo (Democratic) in 2003 to that in 2005?
Your response must be concise. 0.66. What is the ratio of the Domestic credit (% of GDP) in Gambia, The in 2003 to that in 2005?
Provide a succinct answer. 1.22. What is the ratio of the Domestic credit (% of GDP) of Honduras in 2003 to that in 2005?
Provide a succinct answer. 0.95. What is the ratio of the Domestic credit (% of GDP) of Bulgaria in 2003 to that in 2006?
Offer a very short reply. 0.61. What is the ratio of the Domestic credit (% of GDP) of Congo (Democratic) in 2003 to that in 2006?
Your response must be concise. 0.38. What is the ratio of the Domestic credit (% of GDP) in Gambia, The in 2003 to that in 2006?
Ensure brevity in your answer.  1.01. What is the ratio of the Domestic credit (% of GDP) in Honduras in 2003 to that in 2006?
Provide a short and direct response. 0.82. What is the ratio of the Domestic credit (% of GDP) of Bulgaria in 2004 to that in 2005?
Give a very brief answer. 0.85. What is the ratio of the Domestic credit (% of GDP) in Congo (Democratic) in 2004 to that in 2005?
Provide a short and direct response. 0.91. What is the ratio of the Domestic credit (% of GDP) in Gambia, The in 2004 to that in 2005?
Provide a short and direct response. 0.87. What is the ratio of the Domestic credit (% of GDP) in Honduras in 2004 to that in 2005?
Make the answer very short. 0.97. What is the ratio of the Domestic credit (% of GDP) of Bulgaria in 2004 to that in 2006?
Your answer should be very brief. 0.78. What is the ratio of the Domestic credit (% of GDP) of Congo (Democratic) in 2004 to that in 2006?
Your answer should be compact. 0.52. What is the ratio of the Domestic credit (% of GDP) in Gambia, The in 2004 to that in 2006?
Give a very brief answer. 0.72. What is the ratio of the Domestic credit (% of GDP) of Honduras in 2004 to that in 2006?
Ensure brevity in your answer.  0.84. What is the ratio of the Domestic credit (% of GDP) in Bulgaria in 2005 to that in 2006?
Provide a short and direct response. 0.92. What is the ratio of the Domestic credit (% of GDP) in Congo (Democratic) in 2005 to that in 2006?
Keep it short and to the point. 0.57. What is the ratio of the Domestic credit (% of GDP) of Gambia, The in 2005 to that in 2006?
Your answer should be very brief. 0.83. What is the ratio of the Domestic credit (% of GDP) in Honduras in 2005 to that in 2006?
Ensure brevity in your answer.  0.87. What is the difference between the highest and the second highest Domestic credit (% of GDP) in Bulgaria?
Your response must be concise. 3.42. What is the difference between the highest and the second highest Domestic credit (% of GDP) in Congo (Democratic)?
Your answer should be compact. 0.9. What is the difference between the highest and the second highest Domestic credit (% of GDP) in Gambia, The?
Offer a very short reply. 0.15. What is the difference between the highest and the second highest Domestic credit (% of GDP) of Honduras?
Your response must be concise. 5.88. What is the difference between the highest and the lowest Domestic credit (% of GDP) of Bulgaria?
Offer a very short reply. 28.16. What is the difference between the highest and the lowest Domestic credit (% of GDP) in Congo (Democratic)?
Offer a very short reply. 1.61. What is the difference between the highest and the lowest Domestic credit (% of GDP) of Gambia, The?
Your answer should be compact. 3.44. What is the difference between the highest and the lowest Domestic credit (% of GDP) in Honduras?
Ensure brevity in your answer.  8.44. 